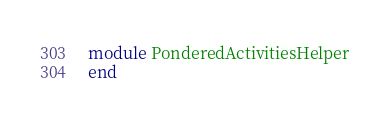<code> <loc_0><loc_0><loc_500><loc_500><_Ruby_>module PonderedActivitiesHelper
end
</code> 